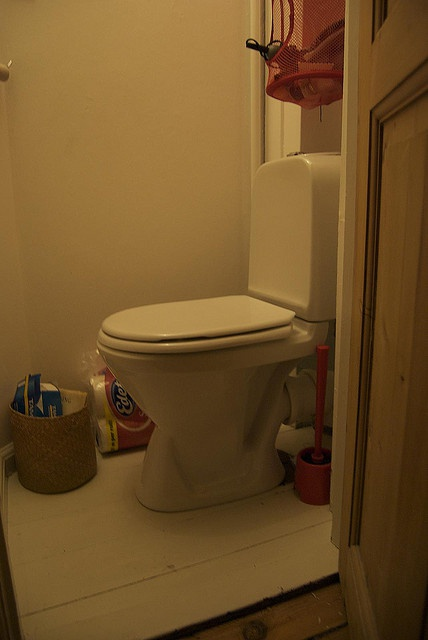Describe the objects in this image and their specific colors. I can see a toilet in olive, maroon, tan, and black tones in this image. 